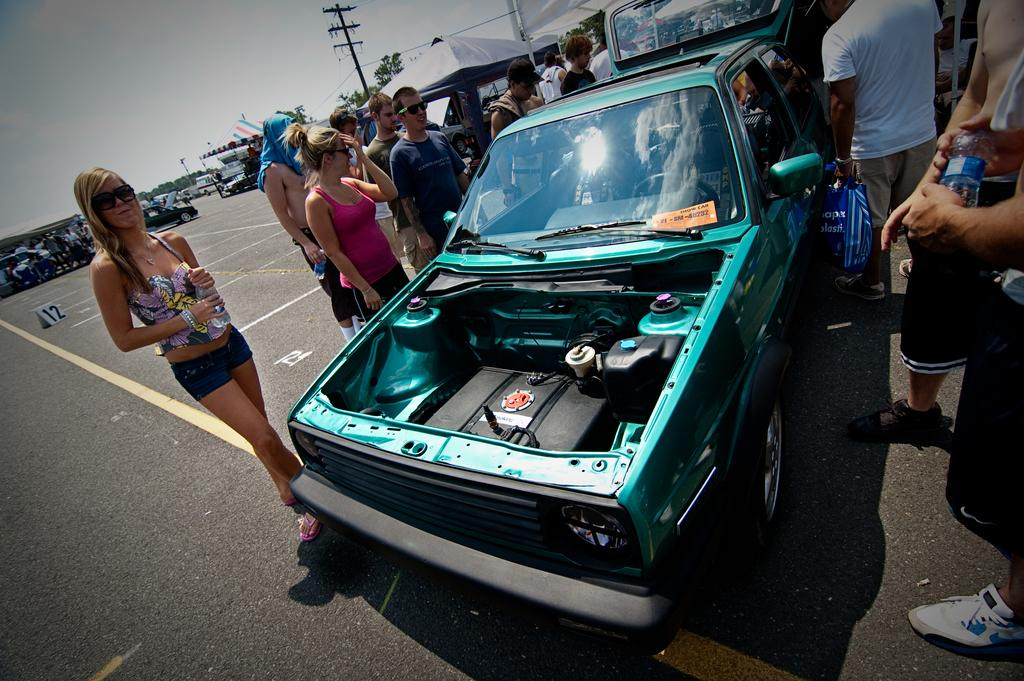What can be seen in the image besides people standing on the road? There are vehicles, trees, tents, streetlights, and the sky visible in the background of the image. Can you describe the vehicles in the image? The facts do not specify the type of vehicles in the image. What is the setting of the image? The image appears to be set on a road with trees, tents, and streetlights in the background. How many eggs are being used to build the earth in the image? There is no reference to eggs or the earth being built in the image. 